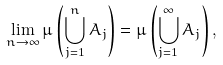<formula> <loc_0><loc_0><loc_500><loc_500>\lim _ { n \to \infty } \mu \left ( \bigcup _ { j = 1 } ^ { n } A _ { j } \right ) = \mu \left ( \bigcup _ { j = 1 } ^ { \infty } A _ { j } \right ) ,</formula> 